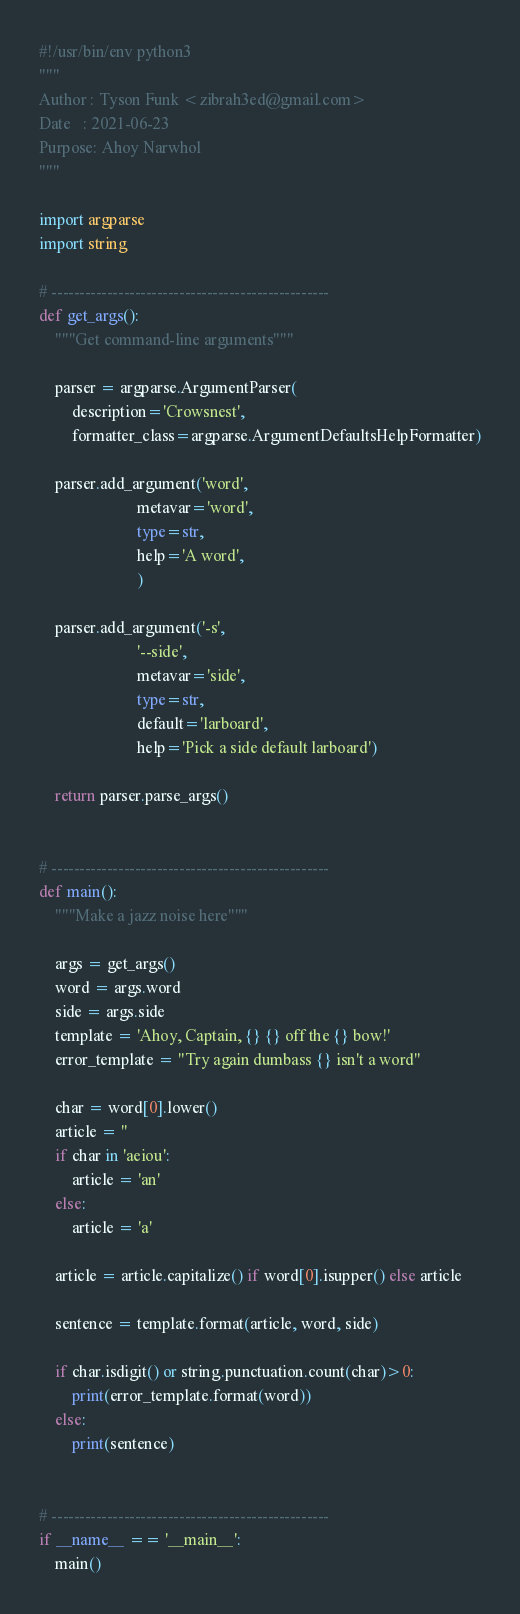Convert code to text. <code><loc_0><loc_0><loc_500><loc_500><_Python_>#!/usr/bin/env python3
"""
Author : Tyson Funk <zibrah3ed@gmail.com>
Date   : 2021-06-23
Purpose: Ahoy Narwhol
"""

import argparse
import string

# --------------------------------------------------
def get_args():
    """Get command-line arguments"""

    parser = argparse.ArgumentParser(
        description='Crowsnest',
        formatter_class=argparse.ArgumentDefaultsHelpFormatter)

    parser.add_argument('word',
                        metavar='word',
                        type=str,
                        help='A word',
                        )

    parser.add_argument('-s',
                        '--side',
                        metavar='side',
                        type=str,
                        default='larboard',
                        help='Pick a side default larboard')

    return parser.parse_args()


# --------------------------------------------------
def main():
    """Make a jazz noise here"""

    args = get_args()
    word = args.word
    side = args.side
    template = 'Ahoy, Captain, {} {} off the {} bow!'
    error_template = "Try again dumbass {} isn't a word"

    char = word[0].lower()
    article = ''
    if char in 'aeiou':
        article = 'an'
    else:
        article = 'a'

    article = article.capitalize() if word[0].isupper() else article

    sentence = template.format(article, word, side)

    if char.isdigit() or string.punctuation.count(char)>0:
        print(error_template.format(word))
    else:
        print(sentence)


# --------------------------------------------------
if __name__ == '__main__':
    main()
</code> 